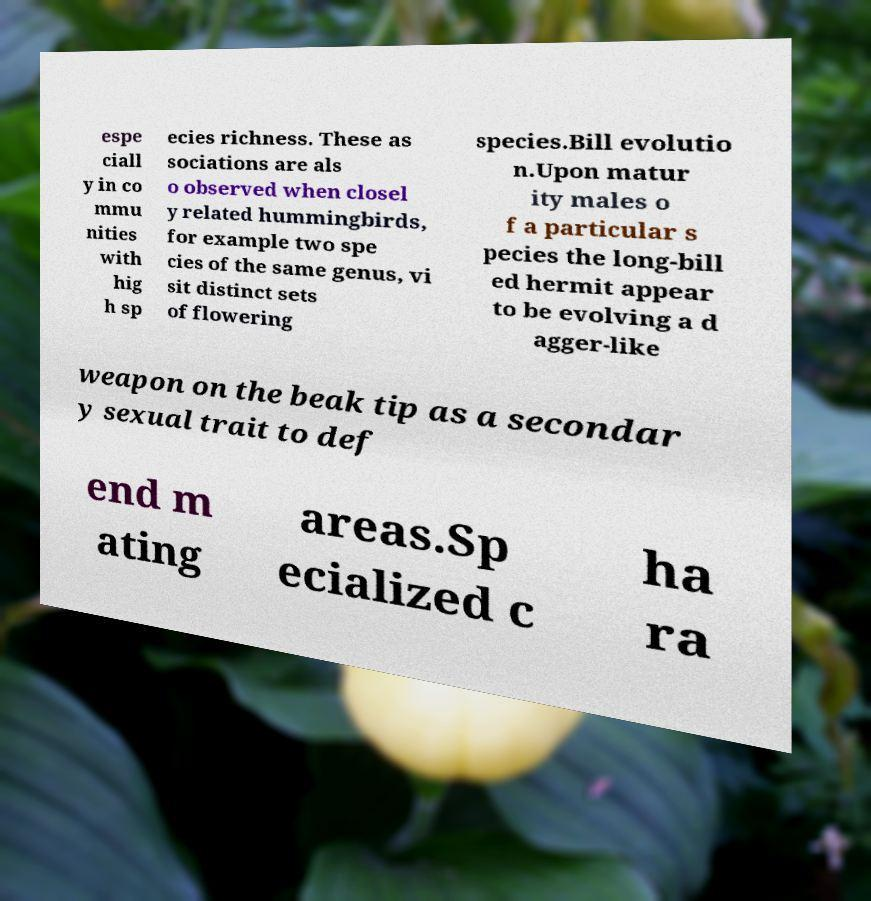For documentation purposes, I need the text within this image transcribed. Could you provide that? espe ciall y in co mmu nities with hig h sp ecies richness. These as sociations are als o observed when closel y related hummingbirds, for example two spe cies of the same genus, vi sit distinct sets of flowering species.Bill evolutio n.Upon matur ity males o f a particular s pecies the long-bill ed hermit appear to be evolving a d agger-like weapon on the beak tip as a secondar y sexual trait to def end m ating areas.Sp ecialized c ha ra 